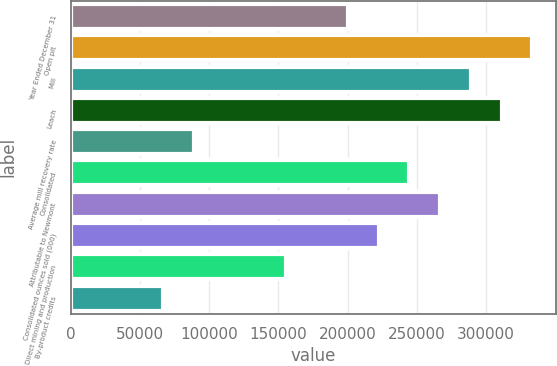Convert chart to OTSL. <chart><loc_0><loc_0><loc_500><loc_500><bar_chart><fcel>Year Ended December 31<fcel>Open pit<fcel>Mill<fcel>Leach<fcel>Average mill recovery rate<fcel>Consolidated<fcel>Attributable to Newmont<fcel>Consolidated ounces sold (000)<fcel>Direct mining and production<fcel>By-product credits<nl><fcel>200000<fcel>333332<fcel>288888<fcel>311110<fcel>88890.6<fcel>244444<fcel>266666<fcel>222222<fcel>155556<fcel>66668.7<nl></chart> 